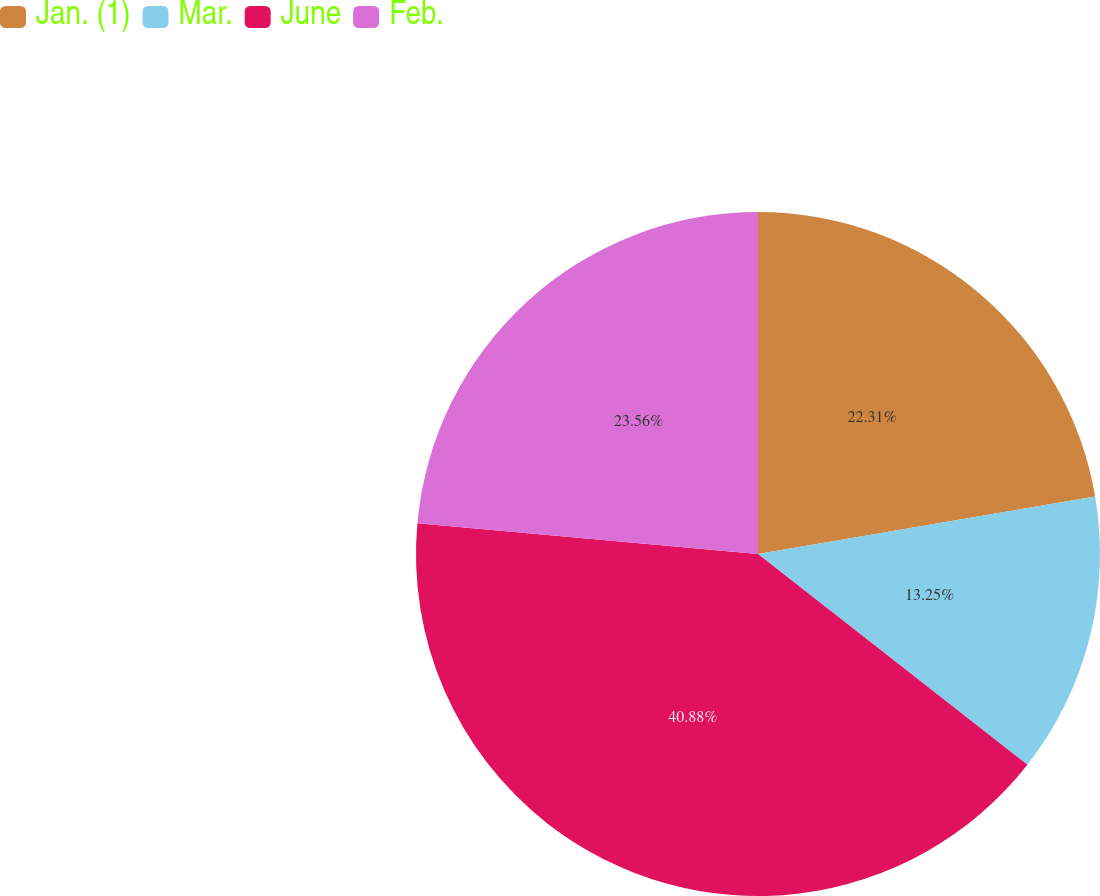<chart> <loc_0><loc_0><loc_500><loc_500><pie_chart><fcel>Jan. (1)<fcel>Mar.<fcel>June<fcel>Feb.<nl><fcel>22.31%<fcel>13.25%<fcel>40.87%<fcel>23.56%<nl></chart> 